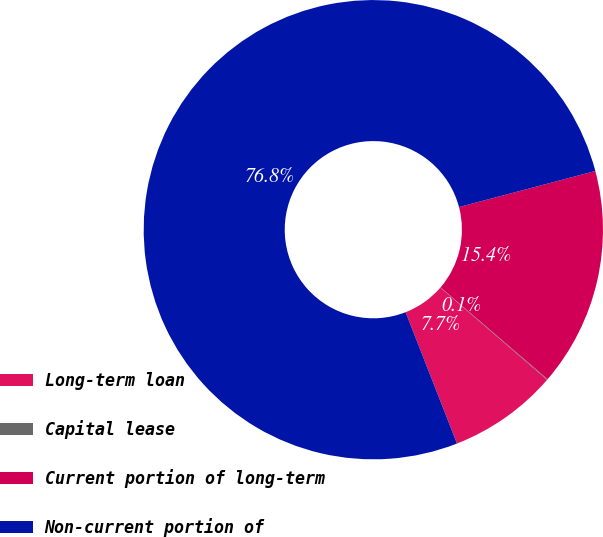Convert chart. <chart><loc_0><loc_0><loc_500><loc_500><pie_chart><fcel>Long-term loan<fcel>Capital lease<fcel>Current portion of long-term<fcel>Non-current portion of<nl><fcel>7.73%<fcel>0.05%<fcel>15.4%<fcel>76.82%<nl></chart> 